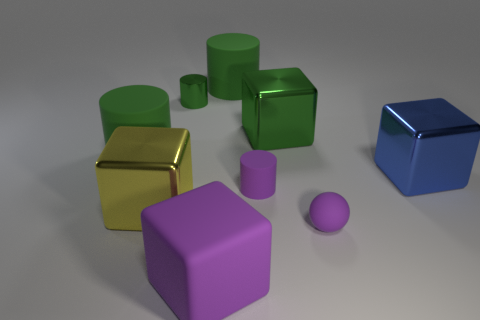Subtract all green cylinders. How many were subtracted if there are1green cylinders left? 2 Subtract all green metal cylinders. How many cylinders are left? 3 Subtract all green cubes. How many cubes are left? 3 Subtract all brown balls. How many purple cylinders are left? 1 Add 1 tiny shiny cylinders. How many objects exist? 10 Subtract 2 cylinders. How many cylinders are left? 2 Add 1 small things. How many small things are left? 4 Add 7 tiny rubber cubes. How many tiny rubber cubes exist? 7 Subtract 1 blue cubes. How many objects are left? 8 Subtract all cylinders. How many objects are left? 5 